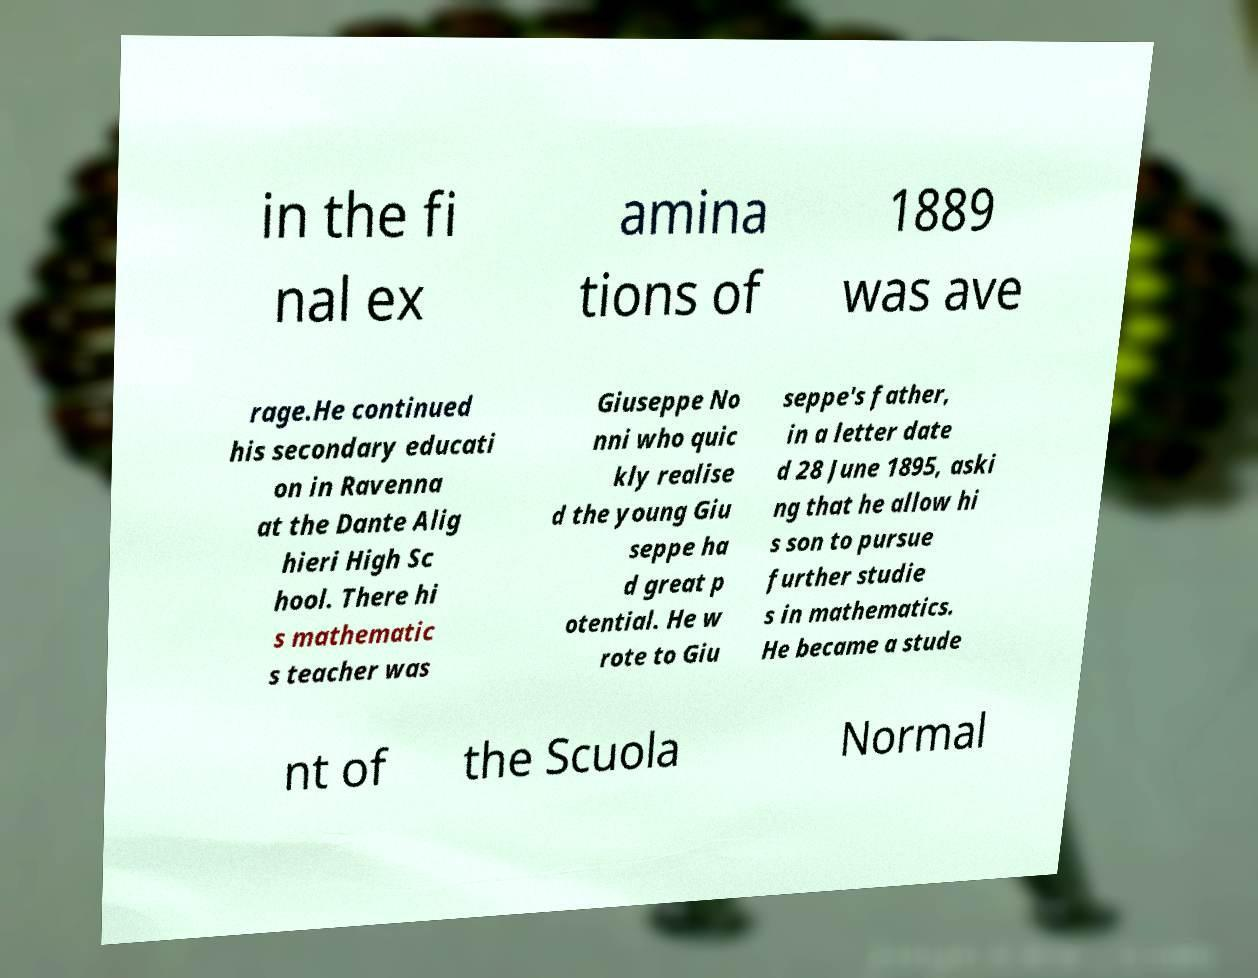I need the written content from this picture converted into text. Can you do that? in the fi nal ex amina tions of 1889 was ave rage.He continued his secondary educati on in Ravenna at the Dante Alig hieri High Sc hool. There hi s mathematic s teacher was Giuseppe No nni who quic kly realise d the young Giu seppe ha d great p otential. He w rote to Giu seppe's father, in a letter date d 28 June 1895, aski ng that he allow hi s son to pursue further studie s in mathematics. He became a stude nt of the Scuola Normal 